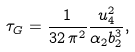<formula> <loc_0><loc_0><loc_500><loc_500>\tau _ { G } = \frac { 1 } { 3 2 \, \pi ^ { 2 } } \frac { u _ { 4 } ^ { 2 } } { \alpha _ { 2 } b _ { 2 } ^ { 3 } } ,</formula> 